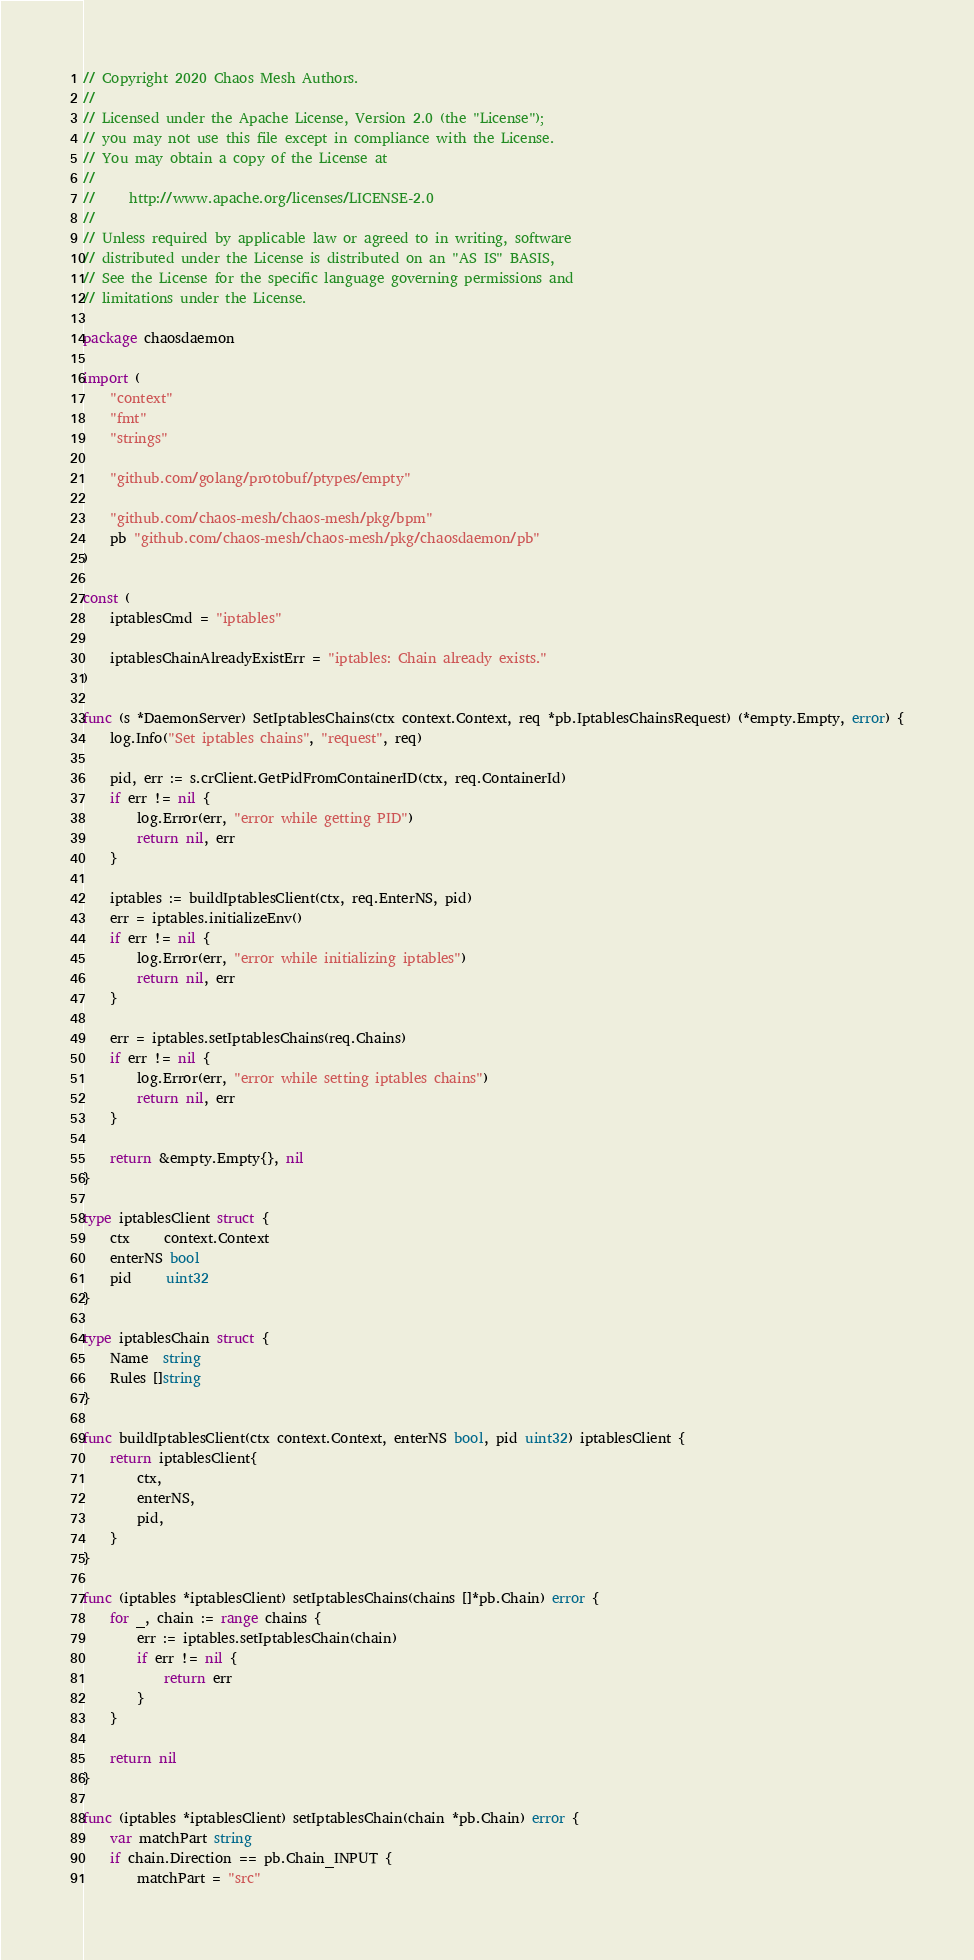<code> <loc_0><loc_0><loc_500><loc_500><_Go_>// Copyright 2020 Chaos Mesh Authors.
//
// Licensed under the Apache License, Version 2.0 (the "License");
// you may not use this file except in compliance with the License.
// You may obtain a copy of the License at
//
//     http://www.apache.org/licenses/LICENSE-2.0
//
// Unless required by applicable law or agreed to in writing, software
// distributed under the License is distributed on an "AS IS" BASIS,
// See the License for the specific language governing permissions and
// limitations under the License.

package chaosdaemon

import (
	"context"
	"fmt"
	"strings"

	"github.com/golang/protobuf/ptypes/empty"

	"github.com/chaos-mesh/chaos-mesh/pkg/bpm"
	pb "github.com/chaos-mesh/chaos-mesh/pkg/chaosdaemon/pb"
)

const (
	iptablesCmd = "iptables"

	iptablesChainAlreadyExistErr = "iptables: Chain already exists."
)

func (s *DaemonServer) SetIptablesChains(ctx context.Context, req *pb.IptablesChainsRequest) (*empty.Empty, error) {
	log.Info("Set iptables chains", "request", req)

	pid, err := s.crClient.GetPidFromContainerID(ctx, req.ContainerId)
	if err != nil {
		log.Error(err, "error while getting PID")
		return nil, err
	}

	iptables := buildIptablesClient(ctx, req.EnterNS, pid)
	err = iptables.initializeEnv()
	if err != nil {
		log.Error(err, "error while initializing iptables")
		return nil, err
	}

	err = iptables.setIptablesChains(req.Chains)
	if err != nil {
		log.Error(err, "error while setting iptables chains")
		return nil, err
	}

	return &empty.Empty{}, nil
}

type iptablesClient struct {
	ctx     context.Context
	enterNS bool
	pid     uint32
}

type iptablesChain struct {
	Name  string
	Rules []string
}

func buildIptablesClient(ctx context.Context, enterNS bool, pid uint32) iptablesClient {
	return iptablesClient{
		ctx,
		enterNS,
		pid,
	}
}

func (iptables *iptablesClient) setIptablesChains(chains []*pb.Chain) error {
	for _, chain := range chains {
		err := iptables.setIptablesChain(chain)
		if err != nil {
			return err
		}
	}

	return nil
}

func (iptables *iptablesClient) setIptablesChain(chain *pb.Chain) error {
	var matchPart string
	if chain.Direction == pb.Chain_INPUT {
		matchPart = "src"</code> 